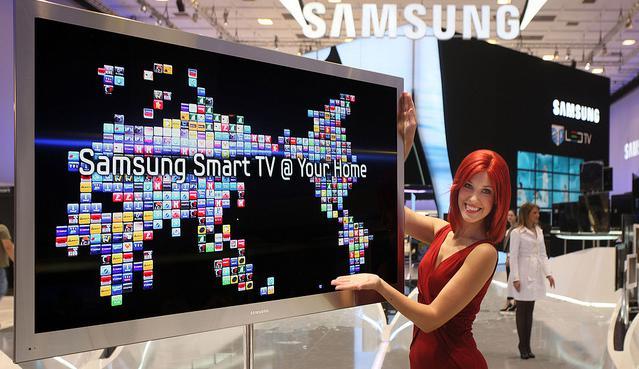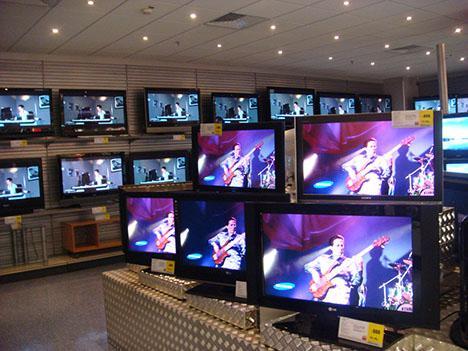The first image is the image on the left, the second image is the image on the right. For the images displayed, is the sentence "In at least one image there is a woman standing to the right of a TV display showing it." factually correct? Answer yes or no. Yes. The first image is the image on the left, the second image is the image on the right. Evaluate the accuracy of this statement regarding the images: "In one image, one woman has one hand at the top of a big-screen TV and is gesturing toward it with the other hand.". Is it true? Answer yes or no. Yes. 